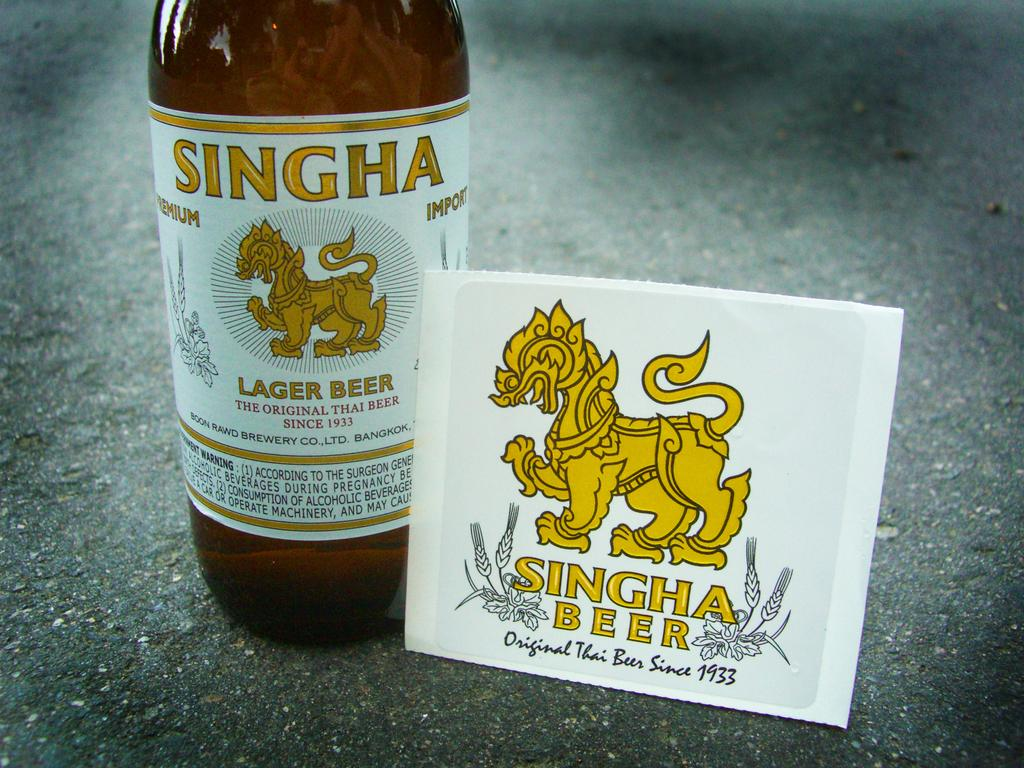<image>
Describe the image concisely. A bottle of beer and a coaster both with a yellow mythical figure and the name SINGHA beer on them. 